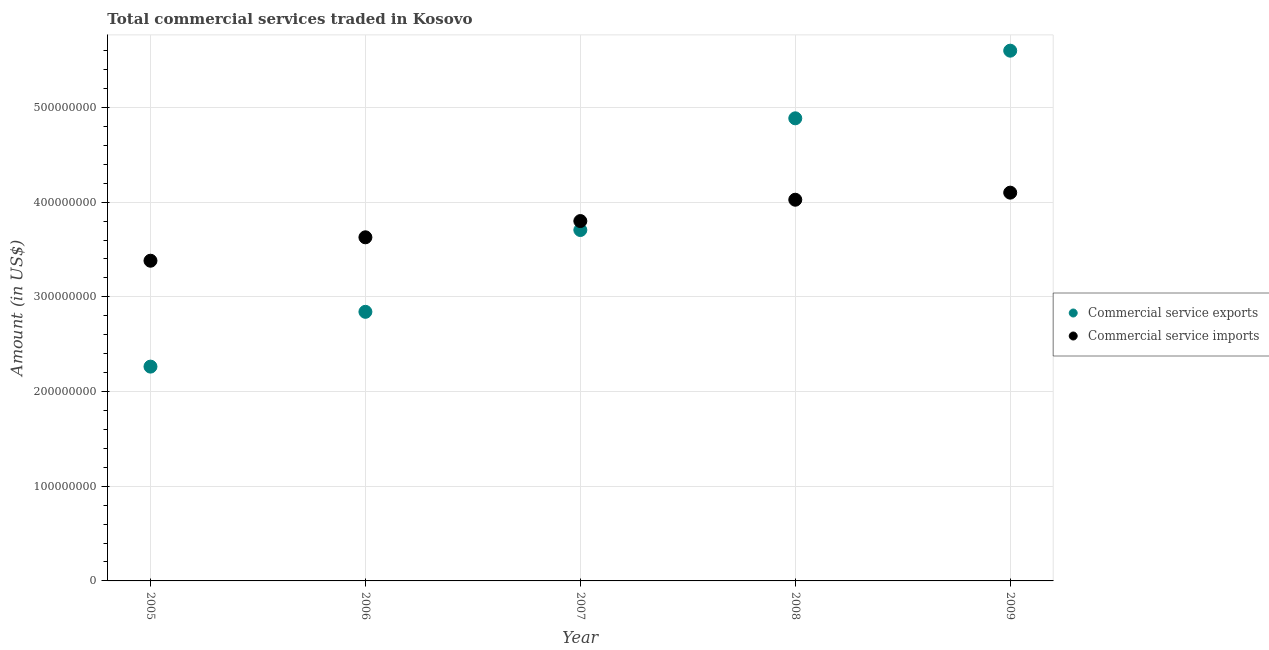How many different coloured dotlines are there?
Offer a terse response. 2. Is the number of dotlines equal to the number of legend labels?
Your response must be concise. Yes. What is the amount of commercial service exports in 2008?
Offer a very short reply. 4.89e+08. Across all years, what is the maximum amount of commercial service imports?
Your answer should be very brief. 4.10e+08. Across all years, what is the minimum amount of commercial service imports?
Your response must be concise. 3.38e+08. In which year was the amount of commercial service imports maximum?
Provide a succinct answer. 2009. What is the total amount of commercial service imports in the graph?
Provide a succinct answer. 1.89e+09. What is the difference between the amount of commercial service imports in 2006 and that in 2008?
Your answer should be very brief. -3.97e+07. What is the difference between the amount of commercial service imports in 2006 and the amount of commercial service exports in 2009?
Provide a succinct answer. -1.97e+08. What is the average amount of commercial service exports per year?
Your answer should be compact. 3.86e+08. In the year 2008, what is the difference between the amount of commercial service imports and amount of commercial service exports?
Give a very brief answer. -8.60e+07. What is the ratio of the amount of commercial service exports in 2005 to that in 2008?
Ensure brevity in your answer.  0.46. Is the difference between the amount of commercial service imports in 2005 and 2007 greater than the difference between the amount of commercial service exports in 2005 and 2007?
Your response must be concise. Yes. What is the difference between the highest and the second highest amount of commercial service imports?
Your answer should be compact. 7.47e+06. What is the difference between the highest and the lowest amount of commercial service imports?
Your answer should be very brief. 7.19e+07. Does the amount of commercial service imports monotonically increase over the years?
Provide a succinct answer. Yes. Is the amount of commercial service exports strictly greater than the amount of commercial service imports over the years?
Ensure brevity in your answer.  No. Is the amount of commercial service imports strictly less than the amount of commercial service exports over the years?
Keep it short and to the point. No. How many dotlines are there?
Make the answer very short. 2. How many years are there in the graph?
Offer a very short reply. 5. What is the difference between two consecutive major ticks on the Y-axis?
Your response must be concise. 1.00e+08. Does the graph contain any zero values?
Give a very brief answer. No. Does the graph contain grids?
Provide a short and direct response. Yes. How many legend labels are there?
Make the answer very short. 2. How are the legend labels stacked?
Provide a succinct answer. Vertical. What is the title of the graph?
Offer a very short reply. Total commercial services traded in Kosovo. Does "Working only" appear as one of the legend labels in the graph?
Your answer should be very brief. No. What is the Amount (in US$) in Commercial service exports in 2005?
Your answer should be compact. 2.26e+08. What is the Amount (in US$) of Commercial service imports in 2005?
Offer a very short reply. 3.38e+08. What is the Amount (in US$) in Commercial service exports in 2006?
Offer a terse response. 2.84e+08. What is the Amount (in US$) of Commercial service imports in 2006?
Your answer should be very brief. 3.63e+08. What is the Amount (in US$) of Commercial service exports in 2007?
Make the answer very short. 3.71e+08. What is the Amount (in US$) in Commercial service imports in 2007?
Offer a terse response. 3.80e+08. What is the Amount (in US$) in Commercial service exports in 2008?
Your response must be concise. 4.89e+08. What is the Amount (in US$) of Commercial service imports in 2008?
Your answer should be very brief. 4.03e+08. What is the Amount (in US$) in Commercial service exports in 2009?
Offer a terse response. 5.60e+08. What is the Amount (in US$) of Commercial service imports in 2009?
Make the answer very short. 4.10e+08. Across all years, what is the maximum Amount (in US$) in Commercial service exports?
Make the answer very short. 5.60e+08. Across all years, what is the maximum Amount (in US$) in Commercial service imports?
Offer a terse response. 4.10e+08. Across all years, what is the minimum Amount (in US$) of Commercial service exports?
Keep it short and to the point. 2.26e+08. Across all years, what is the minimum Amount (in US$) in Commercial service imports?
Ensure brevity in your answer.  3.38e+08. What is the total Amount (in US$) of Commercial service exports in the graph?
Keep it short and to the point. 1.93e+09. What is the total Amount (in US$) of Commercial service imports in the graph?
Provide a succinct answer. 1.89e+09. What is the difference between the Amount (in US$) of Commercial service exports in 2005 and that in 2006?
Your answer should be very brief. -5.79e+07. What is the difference between the Amount (in US$) of Commercial service imports in 2005 and that in 2006?
Offer a terse response. -2.47e+07. What is the difference between the Amount (in US$) of Commercial service exports in 2005 and that in 2007?
Your response must be concise. -1.44e+08. What is the difference between the Amount (in US$) of Commercial service imports in 2005 and that in 2007?
Offer a terse response. -4.19e+07. What is the difference between the Amount (in US$) in Commercial service exports in 2005 and that in 2008?
Your response must be concise. -2.62e+08. What is the difference between the Amount (in US$) in Commercial service imports in 2005 and that in 2008?
Ensure brevity in your answer.  -6.44e+07. What is the difference between the Amount (in US$) of Commercial service exports in 2005 and that in 2009?
Give a very brief answer. -3.34e+08. What is the difference between the Amount (in US$) in Commercial service imports in 2005 and that in 2009?
Your answer should be very brief. -7.19e+07. What is the difference between the Amount (in US$) in Commercial service exports in 2006 and that in 2007?
Ensure brevity in your answer.  -8.64e+07. What is the difference between the Amount (in US$) of Commercial service imports in 2006 and that in 2007?
Offer a terse response. -1.72e+07. What is the difference between the Amount (in US$) of Commercial service exports in 2006 and that in 2008?
Your answer should be very brief. -2.04e+08. What is the difference between the Amount (in US$) of Commercial service imports in 2006 and that in 2008?
Offer a very short reply. -3.97e+07. What is the difference between the Amount (in US$) of Commercial service exports in 2006 and that in 2009?
Provide a succinct answer. -2.76e+08. What is the difference between the Amount (in US$) of Commercial service imports in 2006 and that in 2009?
Your answer should be compact. -4.72e+07. What is the difference between the Amount (in US$) of Commercial service exports in 2007 and that in 2008?
Provide a short and direct response. -1.18e+08. What is the difference between the Amount (in US$) of Commercial service imports in 2007 and that in 2008?
Provide a succinct answer. -2.25e+07. What is the difference between the Amount (in US$) in Commercial service exports in 2007 and that in 2009?
Provide a short and direct response. -1.89e+08. What is the difference between the Amount (in US$) of Commercial service imports in 2007 and that in 2009?
Give a very brief answer. -3.00e+07. What is the difference between the Amount (in US$) in Commercial service exports in 2008 and that in 2009?
Your answer should be very brief. -7.14e+07. What is the difference between the Amount (in US$) in Commercial service imports in 2008 and that in 2009?
Your answer should be compact. -7.47e+06. What is the difference between the Amount (in US$) of Commercial service exports in 2005 and the Amount (in US$) of Commercial service imports in 2006?
Your answer should be very brief. -1.37e+08. What is the difference between the Amount (in US$) in Commercial service exports in 2005 and the Amount (in US$) in Commercial service imports in 2007?
Ensure brevity in your answer.  -1.54e+08. What is the difference between the Amount (in US$) of Commercial service exports in 2005 and the Amount (in US$) of Commercial service imports in 2008?
Your answer should be very brief. -1.76e+08. What is the difference between the Amount (in US$) of Commercial service exports in 2005 and the Amount (in US$) of Commercial service imports in 2009?
Make the answer very short. -1.84e+08. What is the difference between the Amount (in US$) in Commercial service exports in 2006 and the Amount (in US$) in Commercial service imports in 2007?
Ensure brevity in your answer.  -9.59e+07. What is the difference between the Amount (in US$) of Commercial service exports in 2006 and the Amount (in US$) of Commercial service imports in 2008?
Your answer should be very brief. -1.18e+08. What is the difference between the Amount (in US$) of Commercial service exports in 2006 and the Amount (in US$) of Commercial service imports in 2009?
Offer a very short reply. -1.26e+08. What is the difference between the Amount (in US$) in Commercial service exports in 2007 and the Amount (in US$) in Commercial service imports in 2008?
Provide a short and direct response. -3.20e+07. What is the difference between the Amount (in US$) of Commercial service exports in 2007 and the Amount (in US$) of Commercial service imports in 2009?
Your answer should be very brief. -3.95e+07. What is the difference between the Amount (in US$) of Commercial service exports in 2008 and the Amount (in US$) of Commercial service imports in 2009?
Keep it short and to the point. 7.85e+07. What is the average Amount (in US$) in Commercial service exports per year?
Provide a short and direct response. 3.86e+08. What is the average Amount (in US$) of Commercial service imports per year?
Keep it short and to the point. 3.79e+08. In the year 2005, what is the difference between the Amount (in US$) in Commercial service exports and Amount (in US$) in Commercial service imports?
Your answer should be compact. -1.12e+08. In the year 2006, what is the difference between the Amount (in US$) of Commercial service exports and Amount (in US$) of Commercial service imports?
Your answer should be very brief. -7.87e+07. In the year 2007, what is the difference between the Amount (in US$) in Commercial service exports and Amount (in US$) in Commercial service imports?
Ensure brevity in your answer.  -9.48e+06. In the year 2008, what is the difference between the Amount (in US$) in Commercial service exports and Amount (in US$) in Commercial service imports?
Your response must be concise. 8.60e+07. In the year 2009, what is the difference between the Amount (in US$) of Commercial service exports and Amount (in US$) of Commercial service imports?
Give a very brief answer. 1.50e+08. What is the ratio of the Amount (in US$) in Commercial service exports in 2005 to that in 2006?
Make the answer very short. 0.8. What is the ratio of the Amount (in US$) of Commercial service imports in 2005 to that in 2006?
Ensure brevity in your answer.  0.93. What is the ratio of the Amount (in US$) of Commercial service exports in 2005 to that in 2007?
Offer a very short reply. 0.61. What is the ratio of the Amount (in US$) of Commercial service imports in 2005 to that in 2007?
Offer a very short reply. 0.89. What is the ratio of the Amount (in US$) of Commercial service exports in 2005 to that in 2008?
Offer a very short reply. 0.46. What is the ratio of the Amount (in US$) of Commercial service imports in 2005 to that in 2008?
Give a very brief answer. 0.84. What is the ratio of the Amount (in US$) in Commercial service exports in 2005 to that in 2009?
Ensure brevity in your answer.  0.4. What is the ratio of the Amount (in US$) of Commercial service imports in 2005 to that in 2009?
Provide a short and direct response. 0.82. What is the ratio of the Amount (in US$) of Commercial service exports in 2006 to that in 2007?
Give a very brief answer. 0.77. What is the ratio of the Amount (in US$) in Commercial service imports in 2006 to that in 2007?
Give a very brief answer. 0.95. What is the ratio of the Amount (in US$) of Commercial service exports in 2006 to that in 2008?
Give a very brief answer. 0.58. What is the ratio of the Amount (in US$) in Commercial service imports in 2006 to that in 2008?
Give a very brief answer. 0.9. What is the ratio of the Amount (in US$) of Commercial service exports in 2006 to that in 2009?
Provide a succinct answer. 0.51. What is the ratio of the Amount (in US$) of Commercial service imports in 2006 to that in 2009?
Ensure brevity in your answer.  0.89. What is the ratio of the Amount (in US$) in Commercial service exports in 2007 to that in 2008?
Your answer should be very brief. 0.76. What is the ratio of the Amount (in US$) in Commercial service imports in 2007 to that in 2008?
Offer a terse response. 0.94. What is the ratio of the Amount (in US$) in Commercial service exports in 2007 to that in 2009?
Provide a short and direct response. 0.66. What is the ratio of the Amount (in US$) in Commercial service imports in 2007 to that in 2009?
Provide a short and direct response. 0.93. What is the ratio of the Amount (in US$) in Commercial service exports in 2008 to that in 2009?
Offer a very short reply. 0.87. What is the ratio of the Amount (in US$) of Commercial service imports in 2008 to that in 2009?
Keep it short and to the point. 0.98. What is the difference between the highest and the second highest Amount (in US$) of Commercial service exports?
Ensure brevity in your answer.  7.14e+07. What is the difference between the highest and the second highest Amount (in US$) in Commercial service imports?
Your answer should be compact. 7.47e+06. What is the difference between the highest and the lowest Amount (in US$) of Commercial service exports?
Offer a very short reply. 3.34e+08. What is the difference between the highest and the lowest Amount (in US$) of Commercial service imports?
Your answer should be compact. 7.19e+07. 